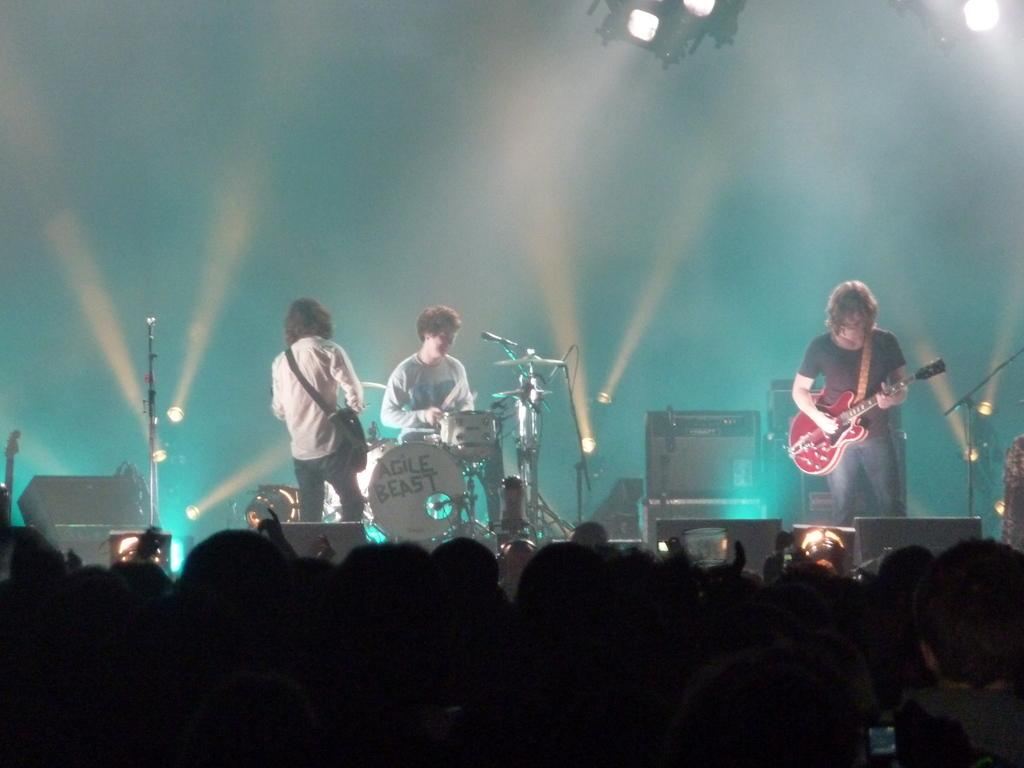What is happening on the stage in the image? There are people on a stage in the image, and some of them are holding guitars. What instrument is being played by one of the performers on stage? At least one person on stage is playing a drum set. Are there any spectators present in the image? Yes, there are people watching the performers on stage. What type of grass is growing on the earth in the image? There is no grass or earth present in the image; it features people on a stage performing with musical instruments. 